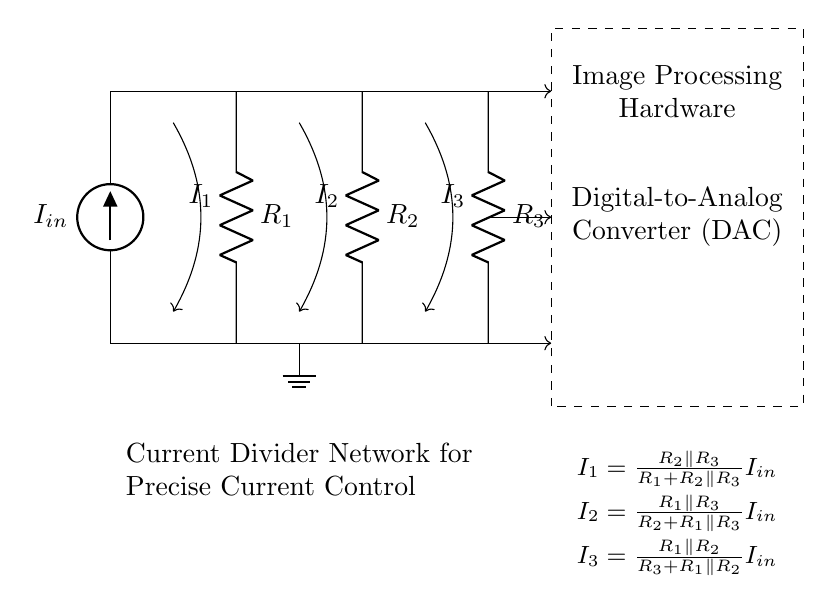What is the input current of the circuit? The input current is denoted as I_in in the circuit diagram, which indicates the main current source feeding into the current divider network.
Answer: I_in What type of resistors are used in this circuit? The resistors R_1, R_2, and R_3 are depicted as standard resistors, which suggests they are passive components that resist the flow of current.
Answer: Resistors How many branches are there in the current divider? The diagram shows three parallel branches for the current divider, indicating that current can be split among three different paths.
Answer: Three Which component is responsible for current division in this circuit? The parallel arrangement of the resistors is responsible for current division, allowing the input current to be split into separate currents through each resistor.
Answer: Resistors How does the current divider affect the digital-to-analog converter? The currents I_1, I_2, and I_3 are supplied to the digital-to-analog converter, which allows for controlled output voltages based on the precise current control enabled by the divider.
Answer: Controlled output voltages 